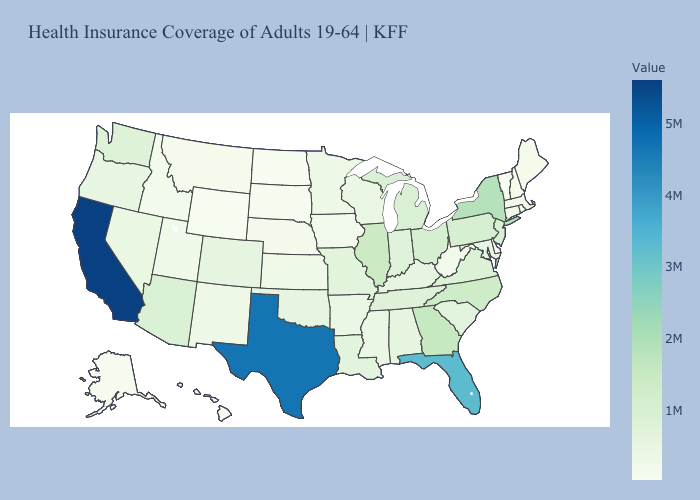Does Nebraska have a lower value than California?
Quick response, please. Yes. Does California have the highest value in the West?
Write a very short answer. Yes. Does California have the highest value in the West?
Quick response, please. Yes. 